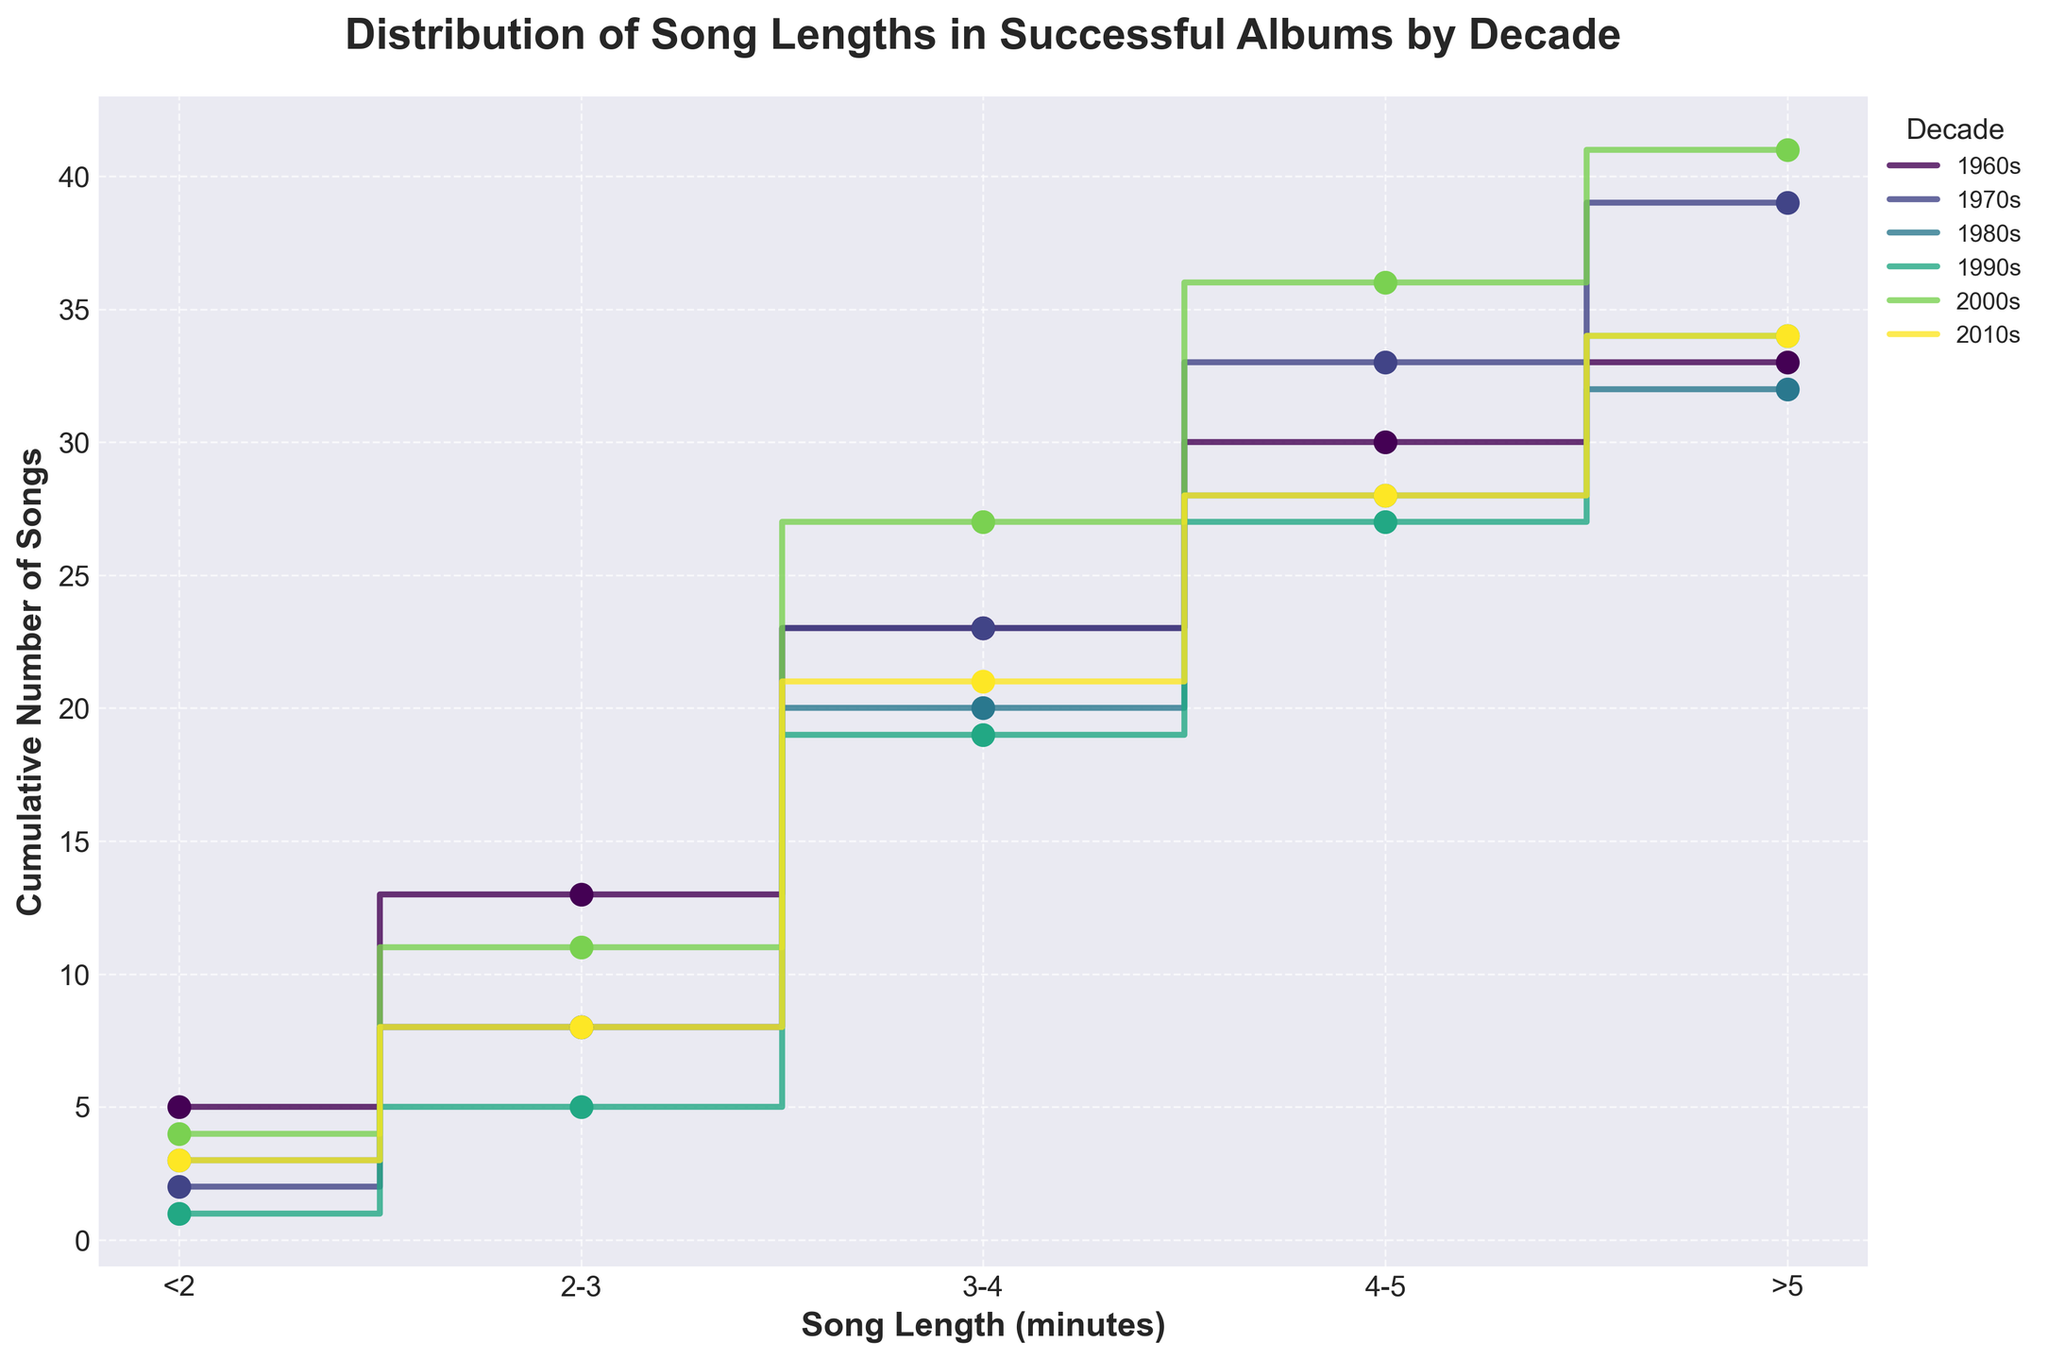How many songs are longer than 5 minutes in the 1970s? Look at the cumulative distribution line for the 1970s. The cumulative number of songs longer than 5 minutes is the final number at the end of the stairs for this decade.
Answer: 6 Which decade has the highest cumulative number of songs in the 3-4 minutes range? For each decade, check the cumulative number for the 3-4 minute song length. Compare these numbers across all decades.
Answer: 2000s In the 2010s, how many songs are in the 2-3 minute range? From the cumulative step corresponding to <2 minutes in the 2010s, calculate the increment up to the next step at 2-3 minutes.
Answer: 5 What is the cumulative number of songs in the 1960s for songs that are up to 4-5 minutes long? Follow the cumulative stairs for the 1960s until the 4-5 minute marker and read the cumulative number.
Answer: 30 Which time range (decade) shows a significantly higher number of songs in the 3-4 minute range compared to <2 minutes? Compare the cumulative numbers of songs in the 3-4 minute range against those in the <2 minute range across all decades.
Answer: 1990s For the 1980s, what is the total number of songs from 4-5 minutes and greater than 5 minutes? For the 1980s, sum the incremental number of songs between the cumulative steps at 4-5 minutes and >5 minutes.
Answer: 12 Which decade saw the smallest number of songs under 2 minutes? Compare the cumulative number of songs under 2 minutes for all decades and determine the smallest value.
Answer: 1990s How does the number of songs in the >5 minutes range for the 2000s compare to the 1970s? Compare the cumulative numbers of songs in the >5 minutes range for both the 2000s and 1970s by looking at the last step of their cumulative stair plots.
Answer: 2000s has fewer In which decade do songs of lengths 4-5 minutes have their highest cumulative count? Check the cumulative numbers at the 4-5 minute length across all decades and find the highest value.
Answer: 1970s What is the difference in the total number of songs between the 1960s and the 2010s? Subtract the total cumulative number of songs at the end of the stairs for the 2010s from that of the 1960s.
Answer: 2 